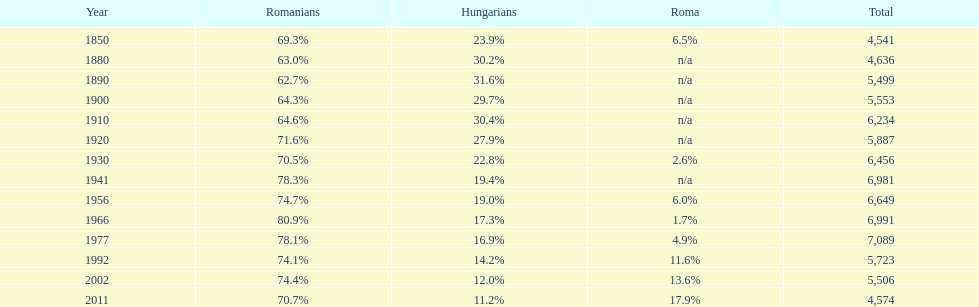Which year had a total of 6,981 and 19.4% hungarians? 1941. 